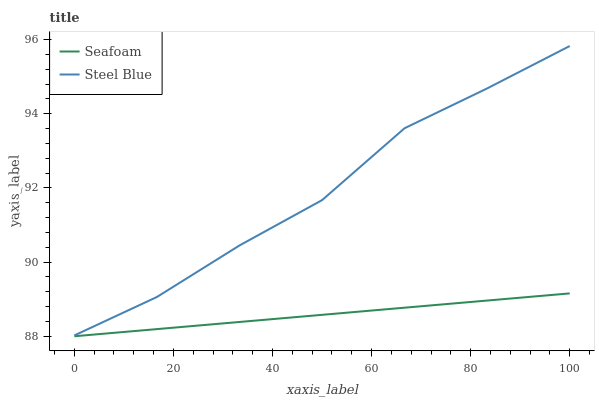Does Seafoam have the minimum area under the curve?
Answer yes or no. Yes. Does Steel Blue have the minimum area under the curve?
Answer yes or no. No. Is Seafoam the smoothest?
Answer yes or no. Yes. Is Steel Blue the roughest?
Answer yes or no. Yes. Is Steel Blue the smoothest?
Answer yes or no. No. Does Steel Blue have the lowest value?
Answer yes or no. No. Is Seafoam less than Steel Blue?
Answer yes or no. Yes. Is Steel Blue greater than Seafoam?
Answer yes or no. Yes. Does Seafoam intersect Steel Blue?
Answer yes or no. No. 